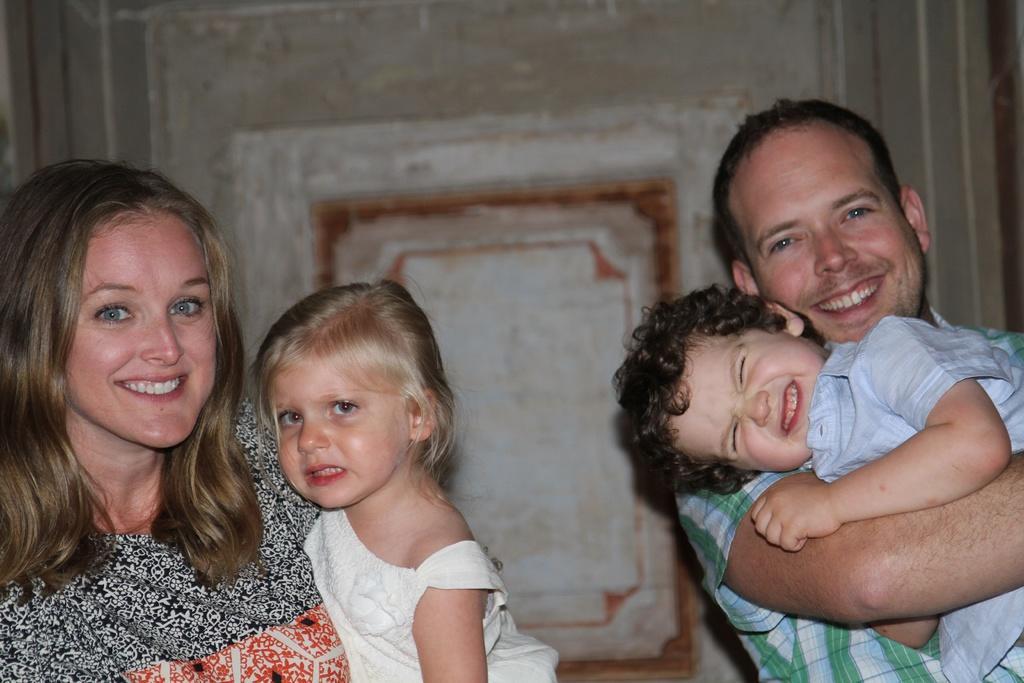Could you give a brief overview of what you see in this image? In this image, we can see a man and a woman standing and they are holding kids, in the background there is a wall. 